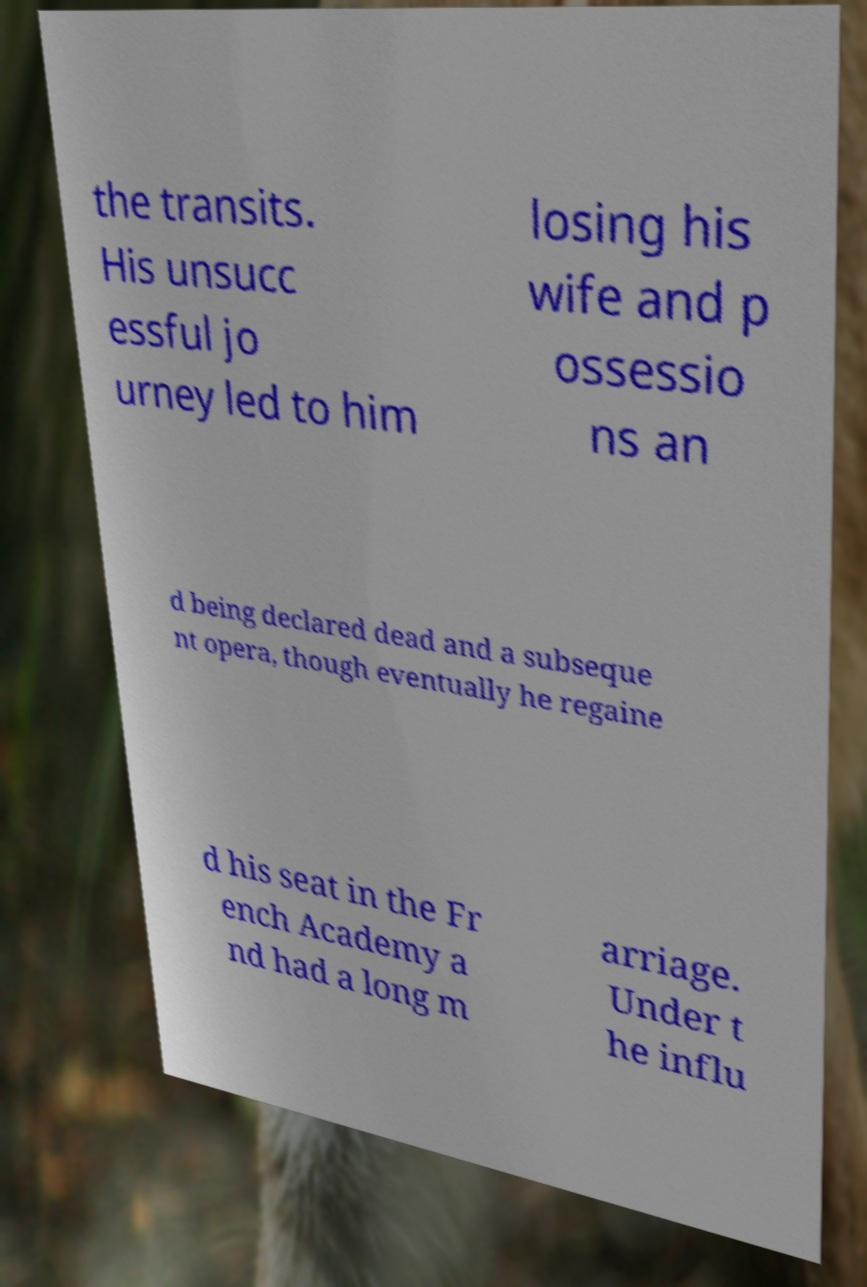Can you read and provide the text displayed in the image?This photo seems to have some interesting text. Can you extract and type it out for me? the transits. His unsucc essful jo urney led to him losing his wife and p ossessio ns an d being declared dead and a subseque nt opera, though eventually he regaine d his seat in the Fr ench Academy a nd had a long m arriage. Under t he influ 